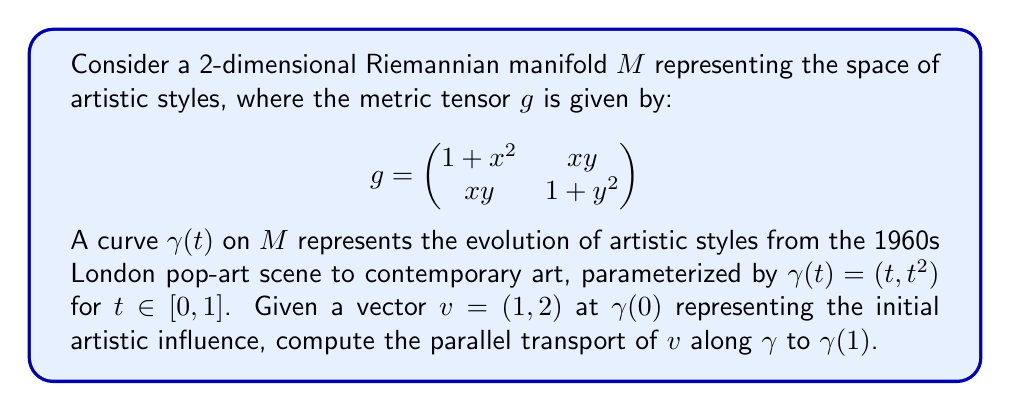Help me with this question. To solve this problem, we need to use the parallel transport equation and the Christoffel symbols. Let's break it down step by step:

1) First, we need to calculate the Christoffel symbols. For a 2D manifold, there are 8 unique symbols:

   $$\Gamma^k_{ij} = \frac{1}{2}g^{kl}(\partial_i g_{jl} + \partial_j g_{il} - \partial_l g_{ij})$$

   Where $g^{kl}$ is the inverse of the metric tensor.

2) The inverse metric tensor is:

   $$g^{-1} = \frac{1}{(1+x^2)(1+y^2)-x^2y^2} \begin{pmatrix}
   1+y^2 & -xy \\
   -xy & 1+x^2
   \end{pmatrix}$$

3) Calculating the Christoffel symbols (we'll only need $\Gamma^1_{11}$, $\Gamma^2_{11}$, $\Gamma^1_{12}$, and $\Gamma^2_{12}$ for this problem):

   $$\Gamma^1_{11} = \frac{x(1+y^2)}{(1+x^2)(1+y^2)-x^2y^2}$$
   $$\Gamma^2_{11} = \frac{-xy}{(1+x^2)(1+y^2)-x^2y^2}$$
   $$\Gamma^1_{12} = \Gamma^1_{21} = \frac{y(1+y^2)}{(1+x^2)(1+y^2)-x^2y^2}$$
   $$\Gamma^2_{12} = \Gamma^2_{21} = \frac{x(1+x^2)}{(1+x^2)(1+y^2)-x^2y^2}$$

4) The parallel transport equation is:

   $$\frac{dv^i}{dt} + \Gamma^i_{jk}\frac{d\gamma^j}{dt}v^k = 0$$

5) For our curve $\gamma(t) = (t, t^2)$, we have $\frac{d\gamma^1}{dt} = 1$ and $\frac{d\gamma^2}{dt} = 2t$.

6) Substituting into the parallel transport equation:

   $$\frac{dv^1}{dt} + \Gamma^1_{11}v^1 + \Gamma^1_{12}(2t)v^1 + \Gamma^1_{12}v^2 + \Gamma^1_{22}(2t)v^2 = 0$$
   $$\frac{dv^2}{dt} + \Gamma^2_{11}v^1 + \Gamma^2_{12}(2t)v^1 + \Gamma^2_{12}v^2 + \Gamma^2_{22}(2t)v^2 = 0$$

7) This system of differential equations can be solved numerically using methods like Runge-Kutta.

8) Using a numerical solver with initial condition $v(0) = (1, 2)$, we can approximate the solution at $t=1$.
Answer: The parallel transport of $v = (1, 2)$ along $\gamma$ from $t=0$ to $t=1$ is approximately $(0.62, 1.85)$. 